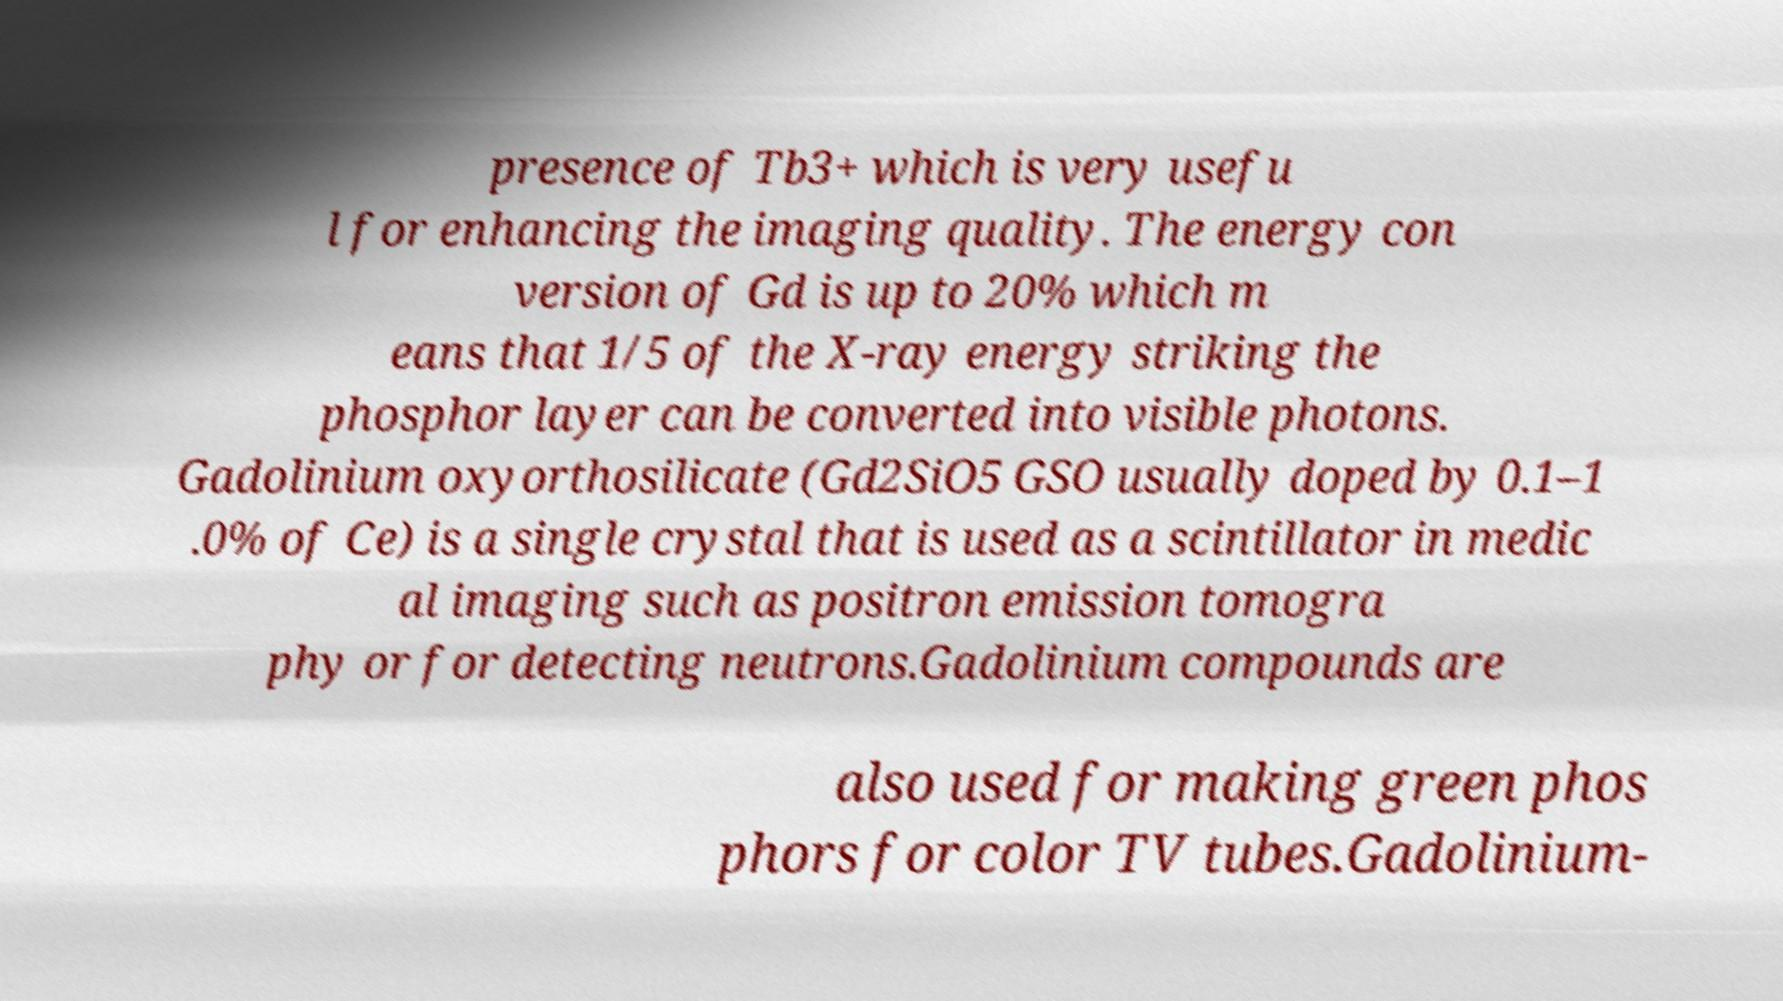What messages or text are displayed in this image? I need them in a readable, typed format. presence of Tb3+ which is very usefu l for enhancing the imaging quality. The energy con version of Gd is up to 20% which m eans that 1/5 of the X-ray energy striking the phosphor layer can be converted into visible photons. Gadolinium oxyorthosilicate (Gd2SiO5 GSO usually doped by 0.1–1 .0% of Ce) is a single crystal that is used as a scintillator in medic al imaging such as positron emission tomogra phy or for detecting neutrons.Gadolinium compounds are also used for making green phos phors for color TV tubes.Gadolinium- 